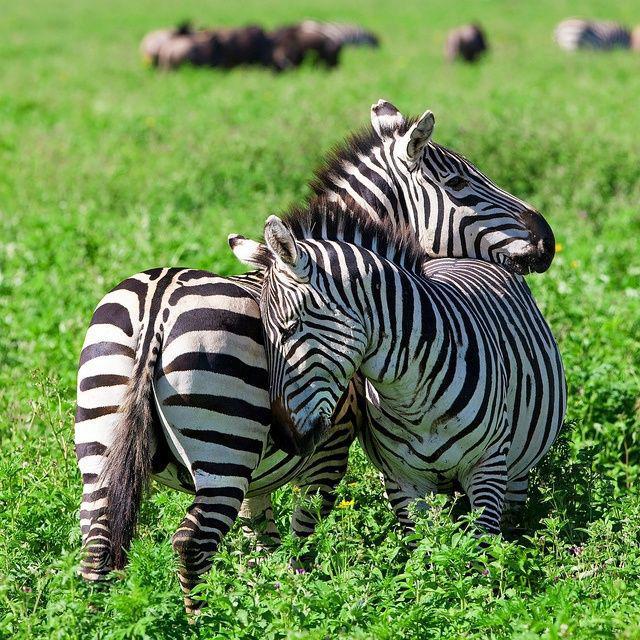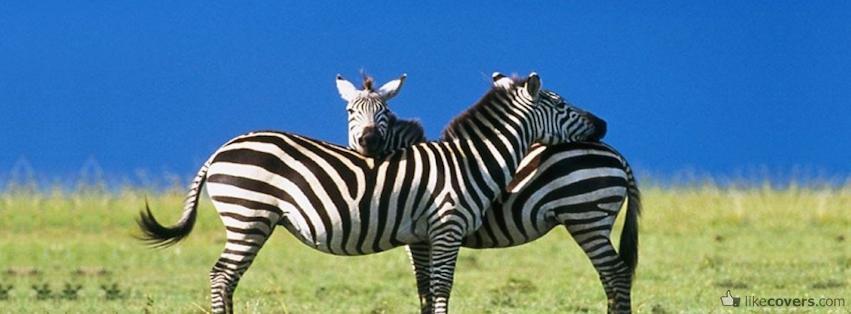The first image is the image on the left, the second image is the image on the right. Examine the images to the left and right. Is the description "The two zebras are standing together in the field resting their heads on one another." accurate? Answer yes or no. No. 